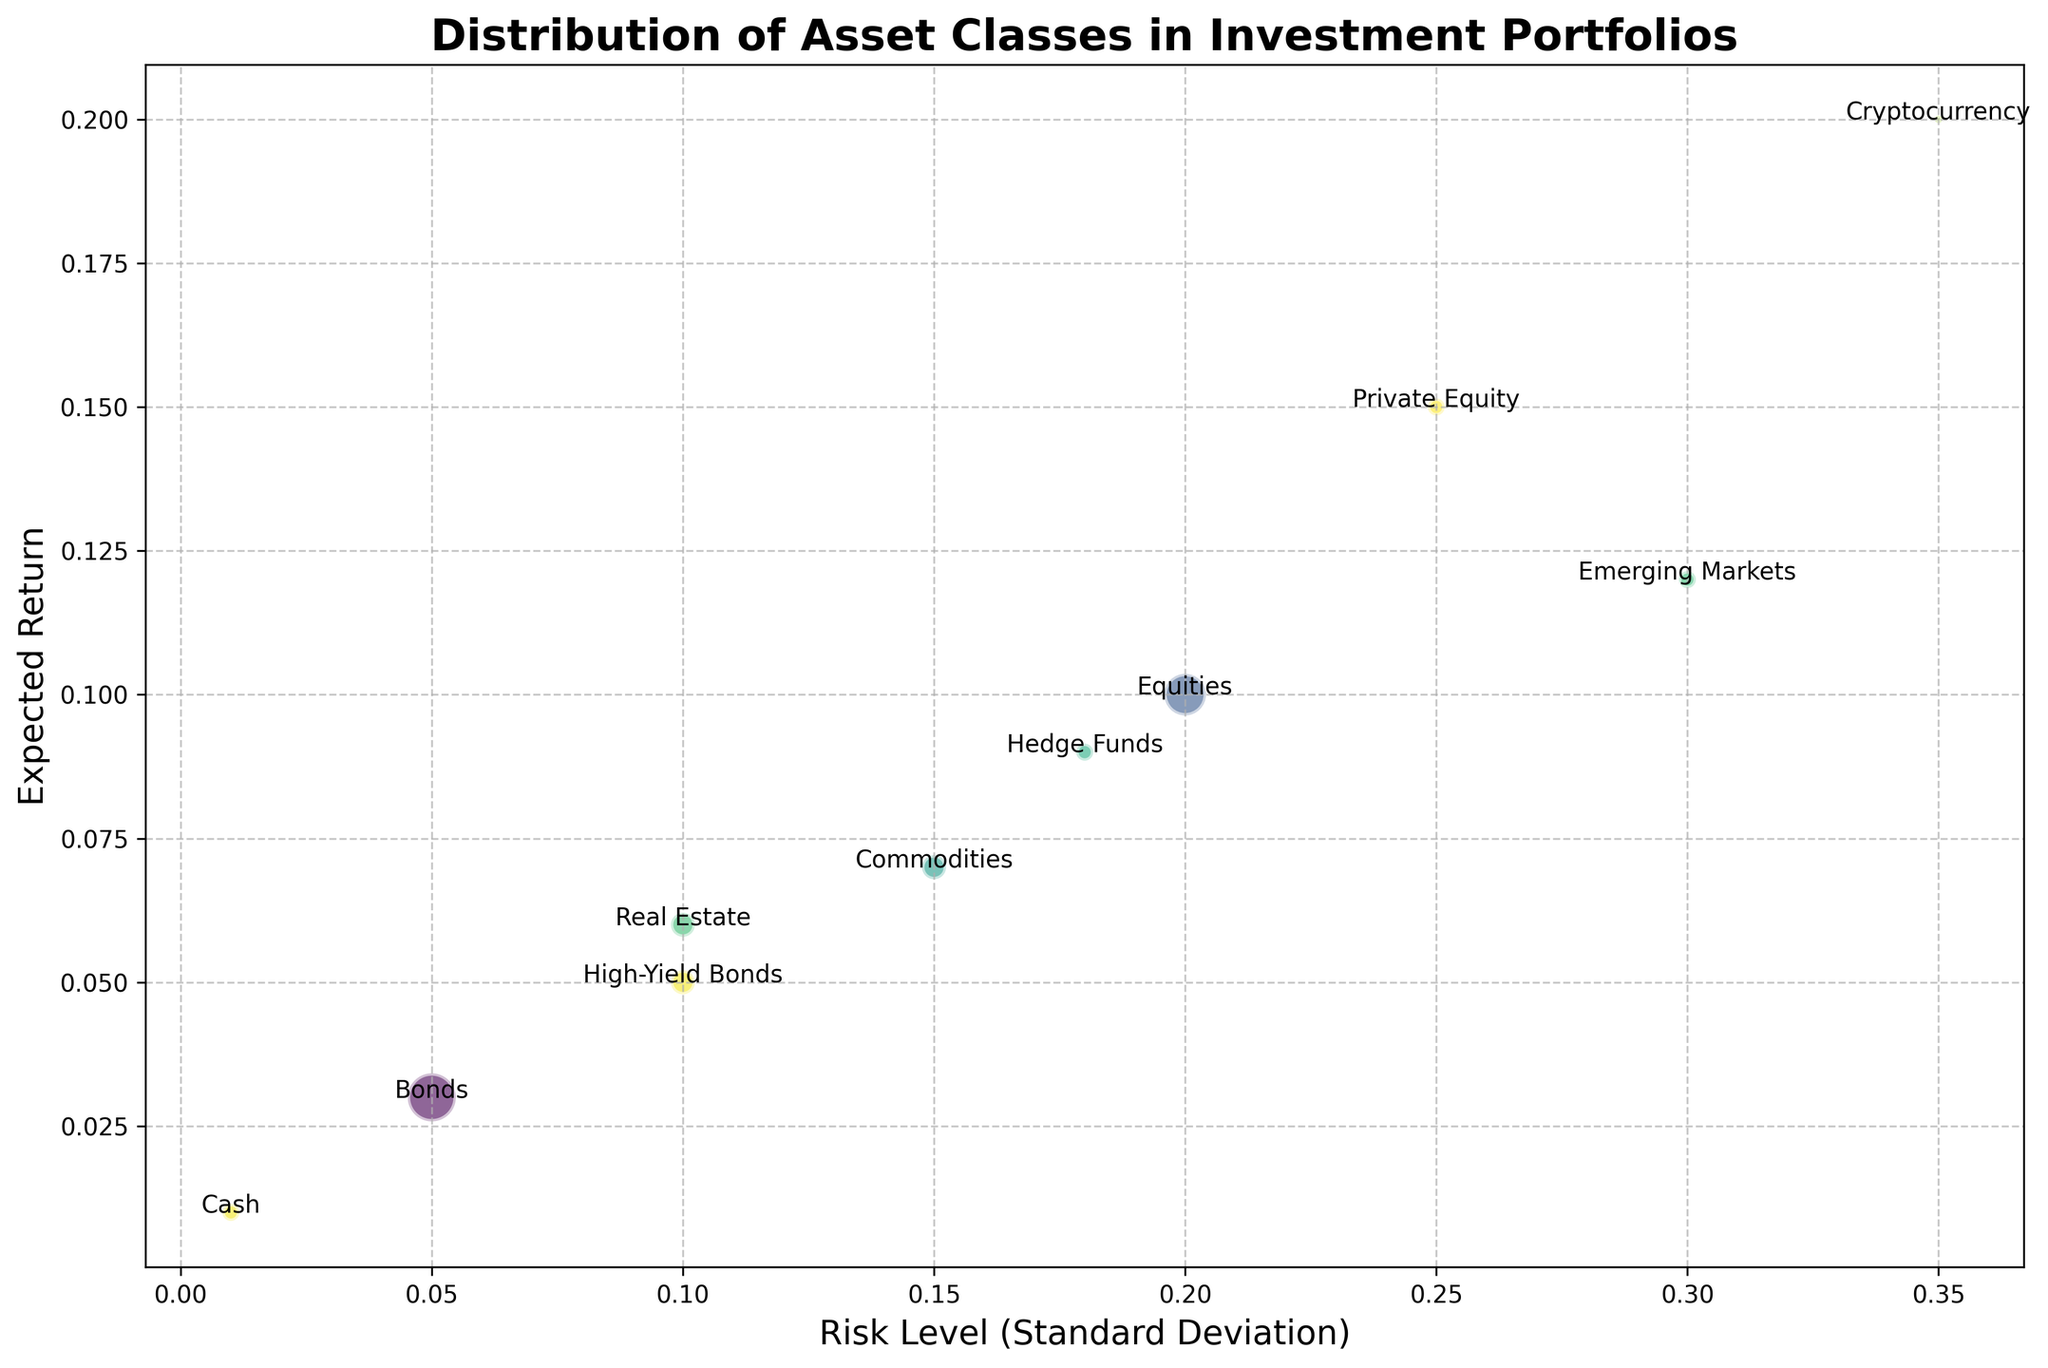What is the asset class with the highest expected return? Look for the bubble positioned at the highest point on the vertical axis (Expected Return). The Cryptocurrency bubble is at 0.20.
Answer: Cryptocurrency Which asset class has the lowest risk level? Identify the bubble positioned at the far left on the horizontal axis (Risk Level). The Cash bubble is at 0.01.
Answer: Cash Among Equities and Bonds, which has a larger proportion of the portfolio? Compare the bubble sizes for Equities and Bonds. The Bonds bubble is larger.
Answer: Bonds What is the risk level difference between Private Equity and Real Estate? Subtract the risk level of Real Estate (0.10) from that of Private Equity (0.25). 0.25 - 0.10 = 0.15.
Answer: 0.15 Which asset class has the same risk level as High-Yield Bonds but a different expected return? Identify any bubble horizontally aligned with High-Yield Bonds at 0.10 but with a differing position on the vertical axis. Both Real Estate and High-Yield Bonds have a risk level of 0.10, but Real Estate has a 0.06 expected return while High-Yield Bonds are at 0.05.
Answer: Real Estate What is the average expected return of asset classes with a risk level above 0.20? Add the expected returns of Private Equity (0.15), Emerging Markets (0.12), and Cryptocurrency (0.20), then divide by 3. (0.15 + 0.12 + 0.20)/3 = 0.1567.
Answer: 0.1567 Which asset class has the smallest proportion in the portfolio? Look for the smallest bubble in the figure. The smallest bubble corresponds to Cryptocurrency.
Answer: Cryptocurrency What is the difference in the expected return between Bonds and Commodities? Subtract the expected return of Bonds (0.03) from that of Commodities (0.07). 0.07 - 0.03 = 0.04.
Answer: 0.04 Is there any asset class with a higher expected return but lower risk level compared to Hedge Funds? Compare bubbles to the right and below Hedge Funds at (0.18, 0.09). Only Equities (0.20, 0.10) and Private Equity (0.25, 0.15) have higher returns but not lower risk.
Answer: No 